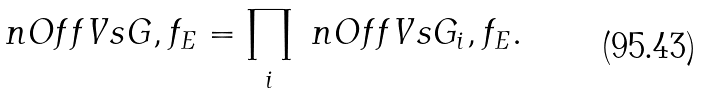<formula> <loc_0><loc_0><loc_500><loc_500>\ n O f f V s { G , f _ { E } } = \prod _ { i } \ n O f f V s { G _ { i } , f _ { E } } .</formula> 